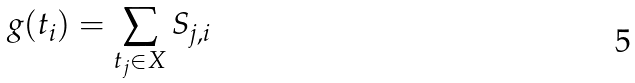<formula> <loc_0><loc_0><loc_500><loc_500>g ( t _ { i } ) = \sum _ { t _ { j } \in X } S _ { j , i }</formula> 